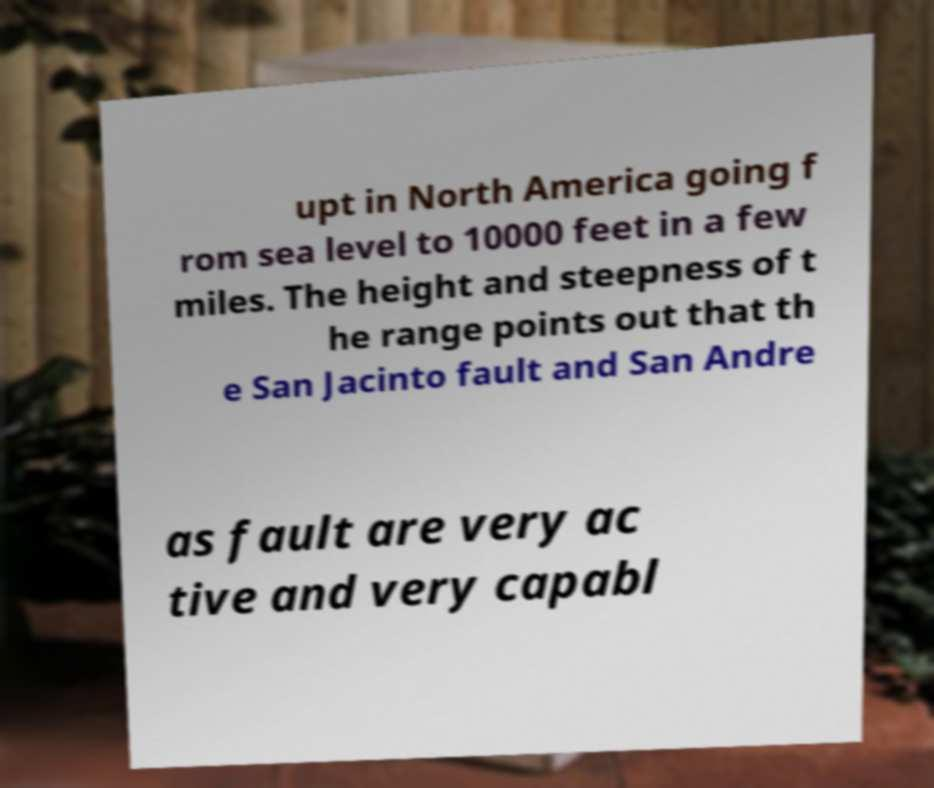Can you read and provide the text displayed in the image?This photo seems to have some interesting text. Can you extract and type it out for me? upt in North America going f rom sea level to 10000 feet in a few miles. The height and steepness of t he range points out that th e San Jacinto fault and San Andre as fault are very ac tive and very capabl 